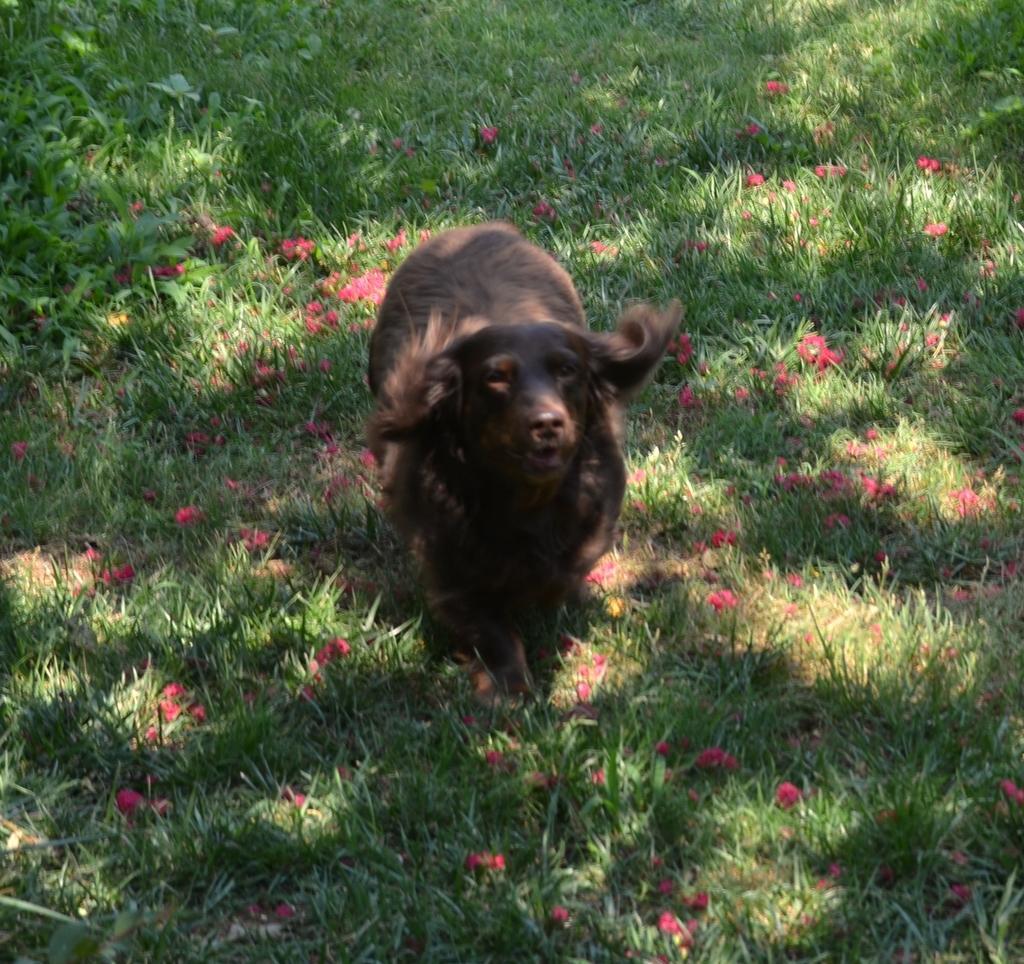Please provide a concise description of this image. In this image we can see an animal on the ground, it is in brown color, there is grass and pink flowers on it. 